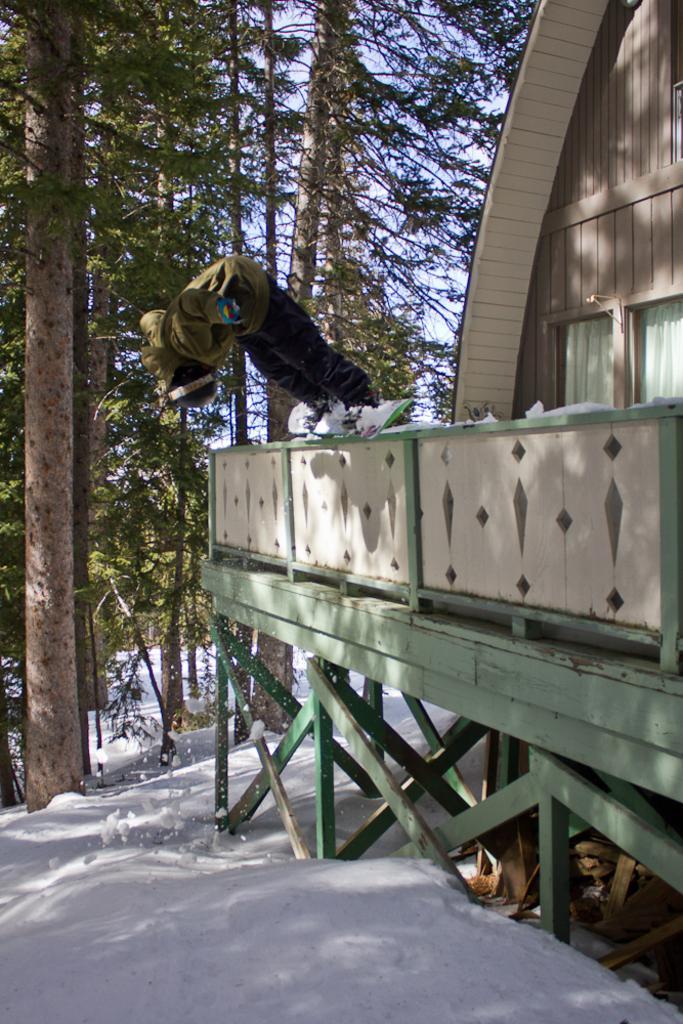How would you summarize this image in a sentence or two? In this image I can see wooden house, fence and other objects. In the background I can see the snow, trees and the sky. 